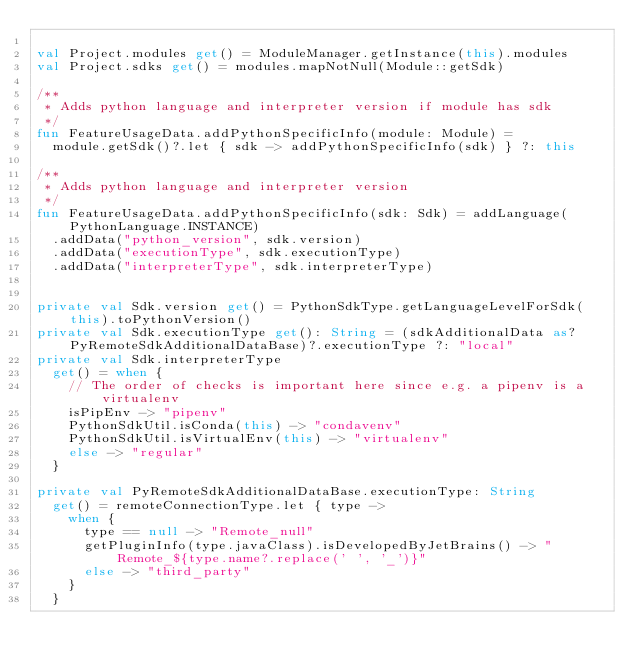<code> <loc_0><loc_0><loc_500><loc_500><_Kotlin_>
val Project.modules get() = ModuleManager.getInstance(this).modules
val Project.sdks get() = modules.mapNotNull(Module::getSdk)

/**
 * Adds python language and interpreter version if module has sdk
 */
fun FeatureUsageData.addPythonSpecificInfo(module: Module) =
  module.getSdk()?.let { sdk -> addPythonSpecificInfo(sdk) } ?: this

/**
 * Adds python language and interpreter version
 */
fun FeatureUsageData.addPythonSpecificInfo(sdk: Sdk) = addLanguage(PythonLanguage.INSTANCE)
  .addData("python_version", sdk.version)
  .addData("executionType", sdk.executionType)
  .addData("interpreterType", sdk.interpreterType)


private val Sdk.version get() = PythonSdkType.getLanguageLevelForSdk(this).toPythonVersion()
private val Sdk.executionType get(): String = (sdkAdditionalData as? PyRemoteSdkAdditionalDataBase)?.executionType ?: "local"
private val Sdk.interpreterType
  get() = when {
    // The order of checks is important here since e.g. a pipenv is a virtualenv
    isPipEnv -> "pipenv"
    PythonSdkUtil.isConda(this) -> "condavenv"
    PythonSdkUtil.isVirtualEnv(this) -> "virtualenv"
    else -> "regular"
  }

private val PyRemoteSdkAdditionalDataBase.executionType: String
  get() = remoteConnectionType.let { type ->
    when {
      type == null -> "Remote_null"
      getPluginInfo(type.javaClass).isDevelopedByJetBrains() -> "Remote_${type.name?.replace(' ', '_')}"
      else -> "third_party"
    }
  }
</code> 